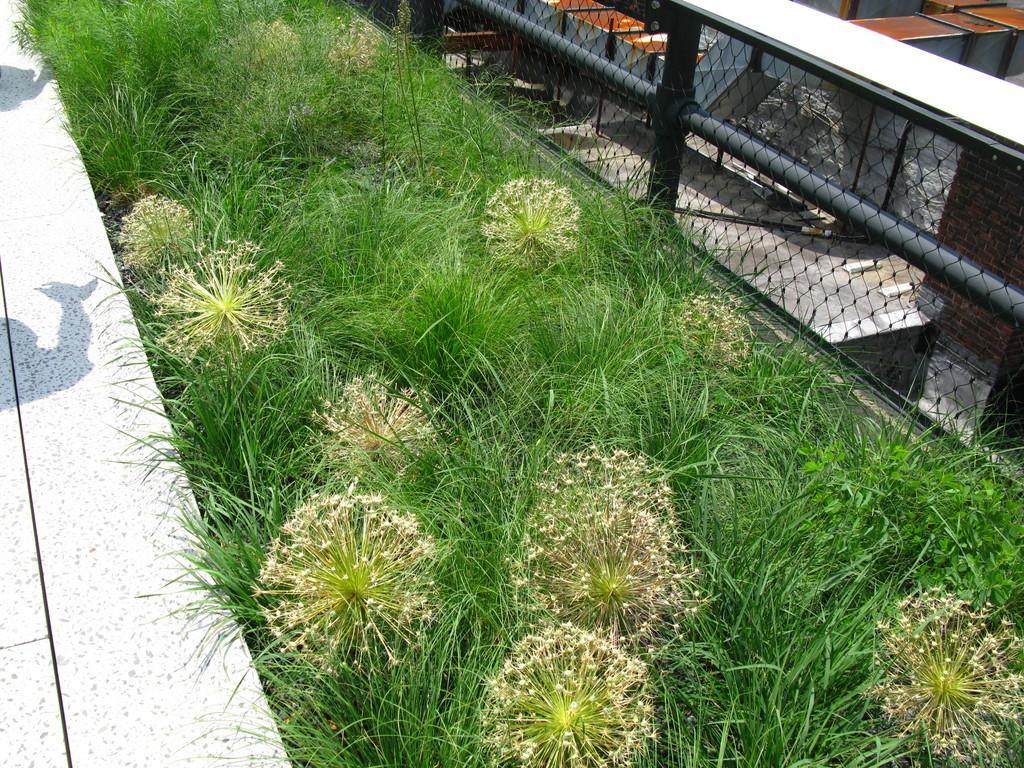In one or two sentences, can you explain what this image depicts? In this image in the front is grass and on the right side there is a metal fence and there are objects which are brown in colour. 